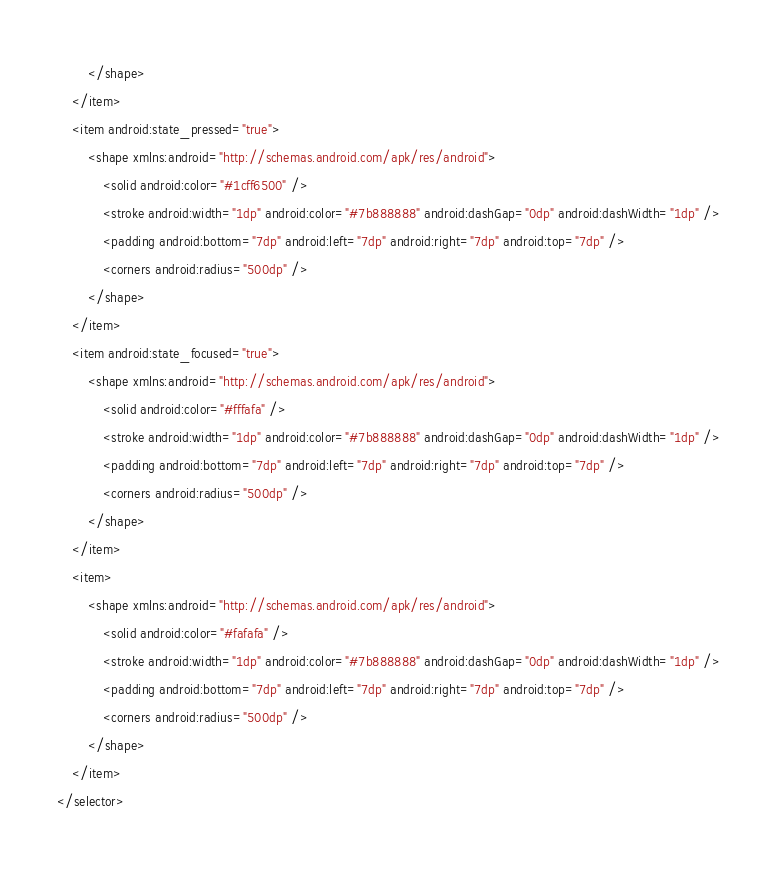<code> <loc_0><loc_0><loc_500><loc_500><_XML_>        </shape>
    </item>
    <item android:state_pressed="true">
        <shape xmlns:android="http://schemas.android.com/apk/res/android">
            <solid android:color="#1cff6500" />
            <stroke android:width="1dp" android:color="#7b888888" android:dashGap="0dp" android:dashWidth="1dp" />
            <padding android:bottom="7dp" android:left="7dp" android:right="7dp" android:top="7dp" />
            <corners android:radius="500dp" />
        </shape>
    </item>
    <item android:state_focused="true">
        <shape xmlns:android="http://schemas.android.com/apk/res/android">
            <solid android:color="#fffafa" />
            <stroke android:width="1dp" android:color="#7b888888" android:dashGap="0dp" android:dashWidth="1dp" />
            <padding android:bottom="7dp" android:left="7dp" android:right="7dp" android:top="7dp" />
            <corners android:radius="500dp" />
        </shape>
    </item>
    <item>
        <shape xmlns:android="http://schemas.android.com/apk/res/android">
            <solid android:color="#fafafa" />
            <stroke android:width="1dp" android:color="#7b888888" android:dashGap="0dp" android:dashWidth="1dp" />
            <padding android:bottom="7dp" android:left="7dp" android:right="7dp" android:top="7dp" />
            <corners android:radius="500dp" />
        </shape>
    </item>
</selector></code> 